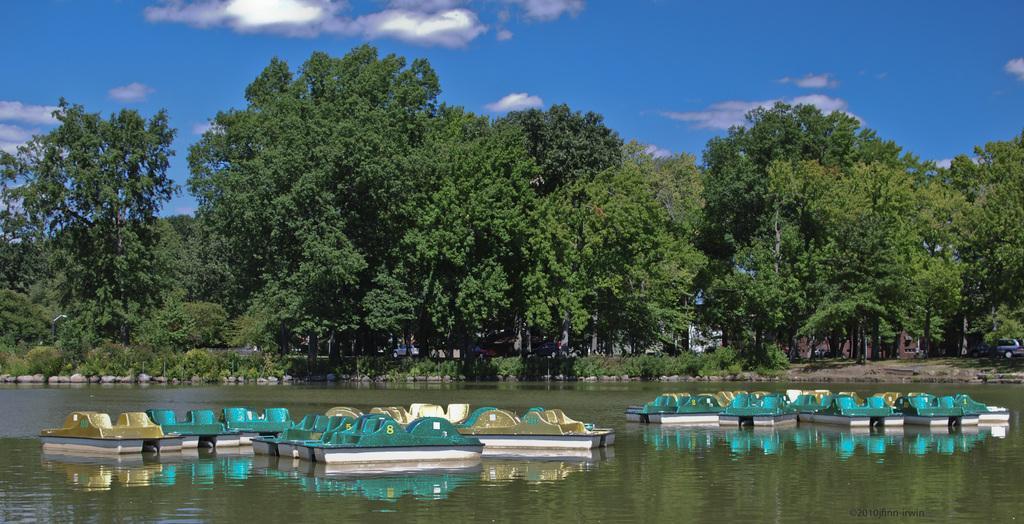Can you describe this image briefly? In this image we can see boats on the water. In the background we can see plants, ground, vehicles, trees, and sky with clouds. 